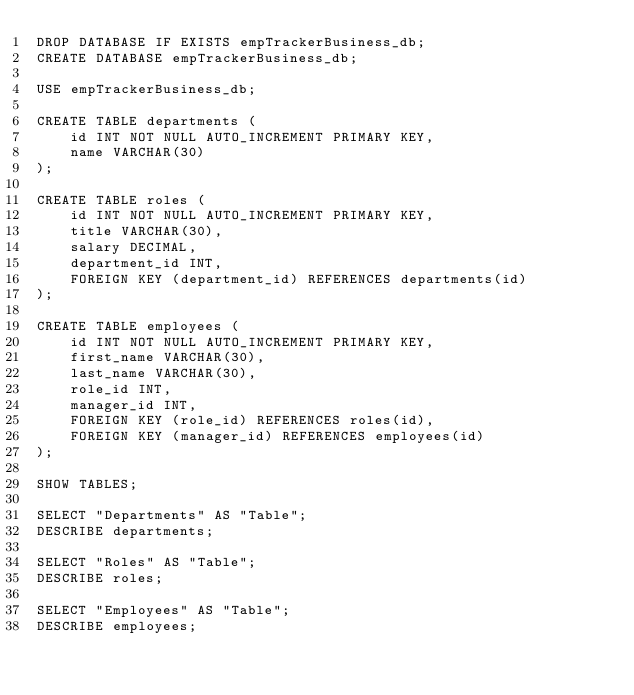<code> <loc_0><loc_0><loc_500><loc_500><_SQL_>DROP DATABASE IF EXISTS empTrackerBusiness_db;
CREATE DATABASE empTrackerBusiness_db;

USE empTrackerBusiness_db;

CREATE TABLE departments (
    id INT NOT NULL AUTO_INCREMENT PRIMARY KEY,
    name VARCHAR(30)
);

CREATE TABLE roles (
    id INT NOT NULL AUTO_INCREMENT PRIMARY KEY,
    title VARCHAR(30),
    salary DECIMAL,
    department_id INT,
    FOREIGN KEY (department_id) REFERENCES departments(id)
);

CREATE TABLE employees (
    id INT NOT NULL AUTO_INCREMENT PRIMARY KEY,
    first_name VARCHAR(30),
    last_name VARCHAR(30),
    role_id INT,
    manager_id INT,
    FOREIGN KEY (role_id) REFERENCES roles(id),
    FOREIGN KEY (manager_id) REFERENCES employees(id)
);

SHOW TABLES;

SELECT "Departments" AS "Table";
DESCRIBE departments;

SELECT "Roles" AS "Table";
DESCRIBE roles;

SELECT "Employees" AS "Table";
DESCRIBE employees;</code> 